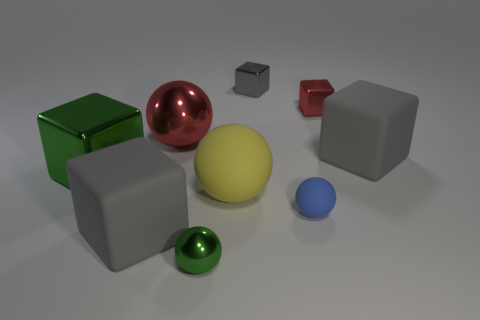Are the ball on the left side of the small green object and the small green thing in front of the blue matte thing made of the same material?
Make the answer very short. Yes. The thing that is the same color as the big metallic block is what shape?
Provide a short and direct response. Sphere. What number of other spheres are the same material as the green ball?
Your answer should be very brief. 1. The large rubber sphere has what color?
Offer a terse response. Yellow. Do the red thing that is left of the tiny green metal thing and the rubber thing in front of the small matte object have the same shape?
Ensure brevity in your answer.  No. What is the color of the matte cube on the right side of the yellow thing?
Give a very brief answer. Gray. Is the number of small blue spheres that are to the left of the tiny metal ball less than the number of gray blocks that are on the left side of the large red object?
Your answer should be compact. Yes. How many other things are the same material as the blue object?
Your response must be concise. 3. Is the material of the large yellow thing the same as the blue thing?
Your answer should be very brief. Yes. What number of other things are there of the same size as the gray shiny object?
Ensure brevity in your answer.  3. 